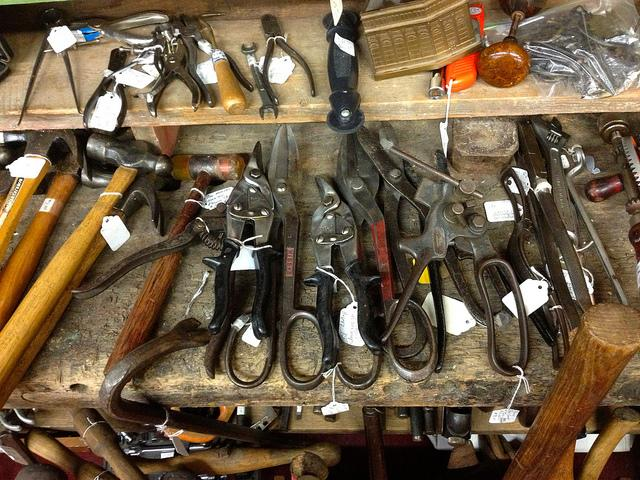Where would these tools be found? Please explain your reasoning. store. They have price tags on them 